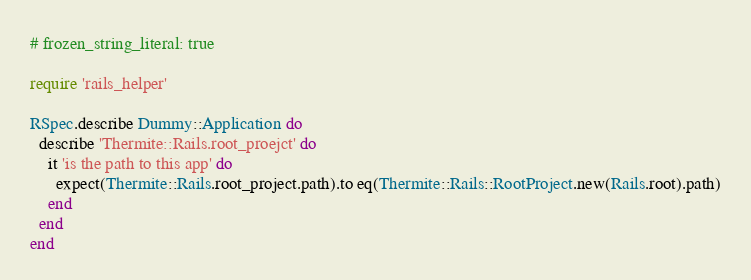<code> <loc_0><loc_0><loc_500><loc_500><_Ruby_># frozen_string_literal: true

require 'rails_helper'

RSpec.describe Dummy::Application do
  describe 'Thermite::Rails.root_proejct' do
    it 'is the path to this app' do
      expect(Thermite::Rails.root_project.path).to eq(Thermite::Rails::RootProject.new(Rails.root).path)
    end
  end
end
</code> 